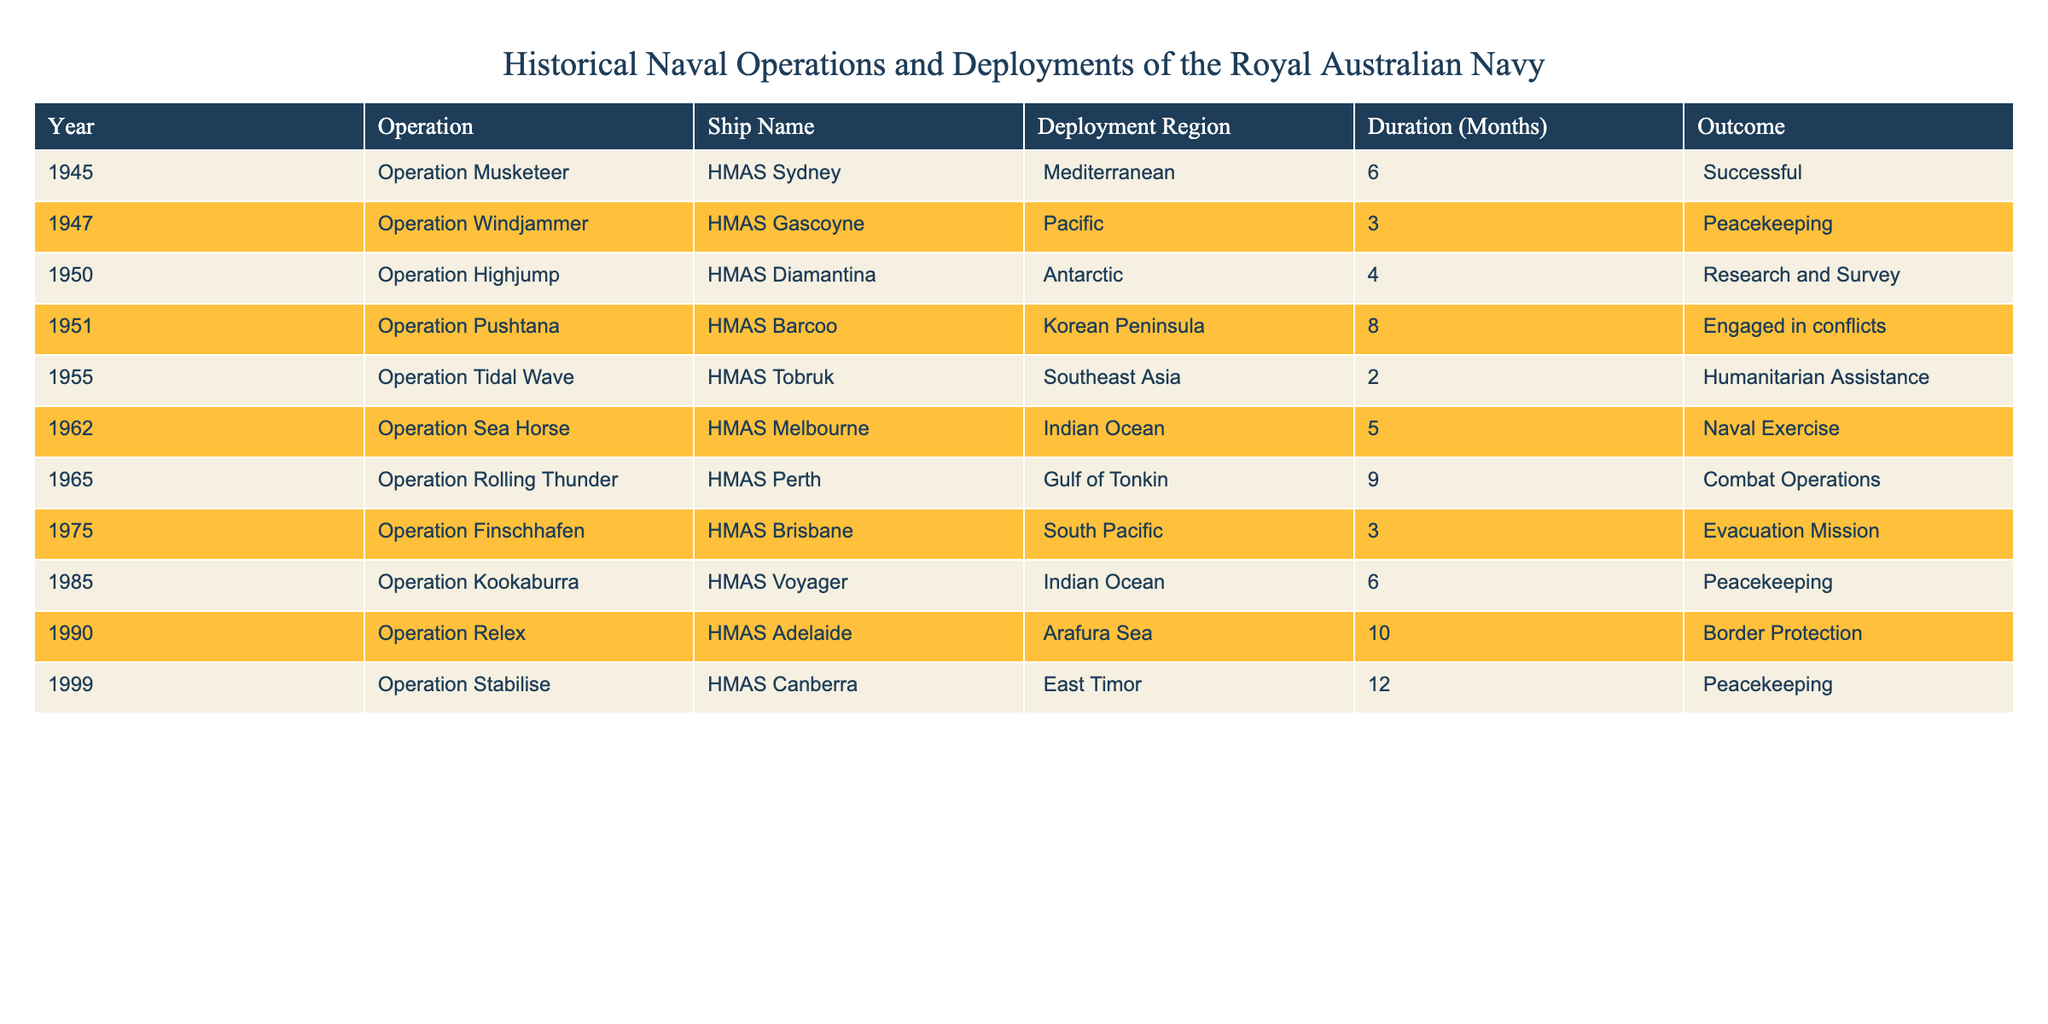What operation did the HMAS Diamantina participate in during 1950? The table shows that the HMAS Diamantina participated in "Operation Highjump" in 1950.
Answer: Operation Highjump How many months did the HMAS Sydney operate in the Mediterranean in 1945? According to the table, the HMAS Sydney was deployed for 6 months during the operation in the Mediterranean in 1945.
Answer: 6 months Which operation was engaged in conflicts on the Korean Peninsula? The table indicates that "Operation Pushtana" involving HMAS Barcoo was engaged in conflicts on the Korean Peninsula in 1951.
Answer: Operation Pushtana Is there any operation that lasted longer than 10 months? Reviewing the table, the longest operation recorded is "Operation Stabilise," which lasted 12 months. Therefore, yes, there is an operation that lasted longer than 10 months.
Answer: Yes What is the average duration of operations in the Indian Ocean as recorded in the table? The table lists two operations in the Indian Ocean: "Operation Sea Horse" with a duration of 5 months and "Operation Kookaburra" with a duration of 6 months. Summing these gives 11 months and dividing by 2 operations gives an average of 5.5 months.
Answer: 5.5 months What was the outcome of the HMAS Perth during Operation Rolling Thunder? From the table, we can see that the outcome for HMAS Perth during "Operation Rolling Thunder" was "Combat Operations."
Answer: Combat Operations Were there any peacekeeping missions conducted by the Royal Australian Navy in the Pacific? By analyzing the table, we find "Operation Windjammer" in 1947 and "Operation Kookaburra" in 1985; both have declared peacekeeping outcomes, indicating that there were peacekeeping missions in the Pacific.
Answer: Yes Which operation had the shortest duration, and what was that duration? The table reveals that "Operation Tidal Wave" conducted by HMAS Tobruk had the shortest duration of 2 months, making it the briefest operation listed.
Answer: 2 months How many operations were conducted in the Antarctic region? The table indicates only one operation in the Antarctic region, which is "Operation Highjump" involving the HMAS Diamantina, thus answering the question.
Answer: 1 operation 